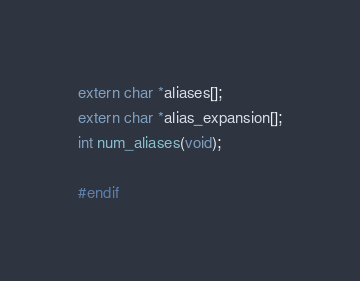<code> <loc_0><loc_0><loc_500><loc_500><_C_>extern char *aliases[];
extern char *alias_expansion[];
int num_aliases(void);

#endif
</code> 